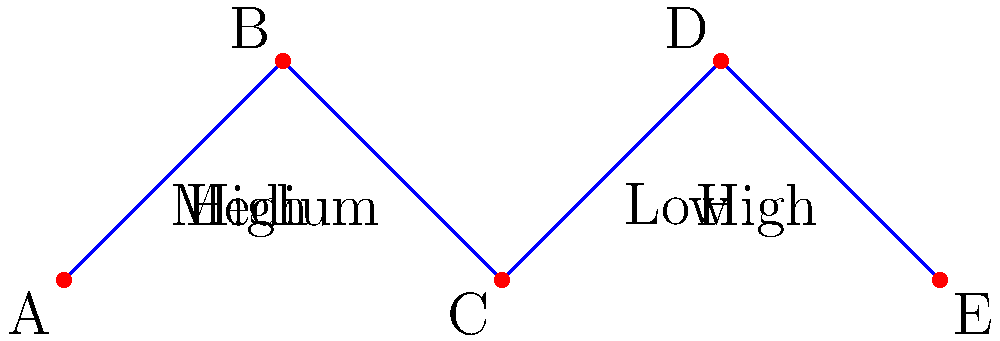In the diagram above, the vertices represent critical points on a ship's hull, and the edges represent connections between these points. The labels on the edges indicate stress levels during extreme weather conditions. Using graph coloring techniques, what is the minimum number of colors needed to ensure that no two adjacent vertices have the same color, while also prioritizing high-stress areas? To solve this problem, we'll use a modified graph coloring approach that prioritizes high-stress areas:

1. Identify high-stress areas:
   - Edge AB and DE are labeled "High"

2. Prioritize coloring vertices connected by high-stress edges:
   - Start with vertex A (color 1)
   - B must be different (color 2)
   - E must be different from D (if D is colored)

3. Color remaining vertices:
   - C can be the same as A (color 1)
   - D must be different from C and E (color 3)

4. Check if the coloring is valid:
   - A (color 1) - B (color 2)
   - B (color 2) - C (color 1)
   - C (color 1) - D (color 3)
   - D (color 3) - E (color 2)

5. Verify that high-stress areas have different colors:
   - AB: color 1 and color 2 (different)
   - DE: color 3 and color 2 (different)

The minimum number of colors needed is 3, which satisfies the condition that no two adjacent vertices have the same color while prioritizing high-stress areas.
Answer: 3 colors 